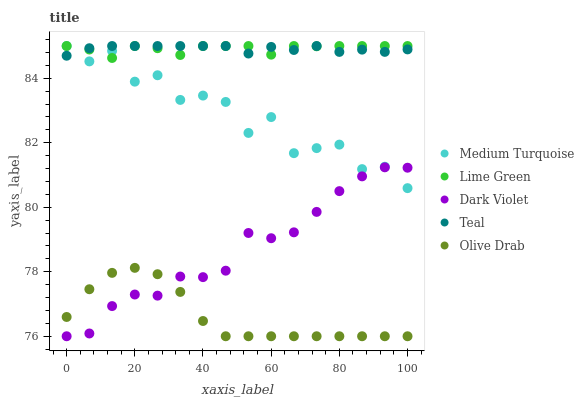Does Olive Drab have the minimum area under the curve?
Answer yes or no. Yes. Does Lime Green have the maximum area under the curve?
Answer yes or no. Yes. Does Lime Green have the minimum area under the curve?
Answer yes or no. No. Does Olive Drab have the maximum area under the curve?
Answer yes or no. No. Is Teal the smoothest?
Answer yes or no. Yes. Is Medium Turquoise the roughest?
Answer yes or no. Yes. Is Olive Drab the smoothest?
Answer yes or no. No. Is Olive Drab the roughest?
Answer yes or no. No. Does Olive Drab have the lowest value?
Answer yes or no. Yes. Does Lime Green have the lowest value?
Answer yes or no. No. Does Medium Turquoise have the highest value?
Answer yes or no. Yes. Does Olive Drab have the highest value?
Answer yes or no. No. Is Olive Drab less than Lime Green?
Answer yes or no. Yes. Is Lime Green greater than Olive Drab?
Answer yes or no. Yes. Does Dark Violet intersect Medium Turquoise?
Answer yes or no. Yes. Is Dark Violet less than Medium Turquoise?
Answer yes or no. No. Is Dark Violet greater than Medium Turquoise?
Answer yes or no. No. Does Olive Drab intersect Lime Green?
Answer yes or no. No. 